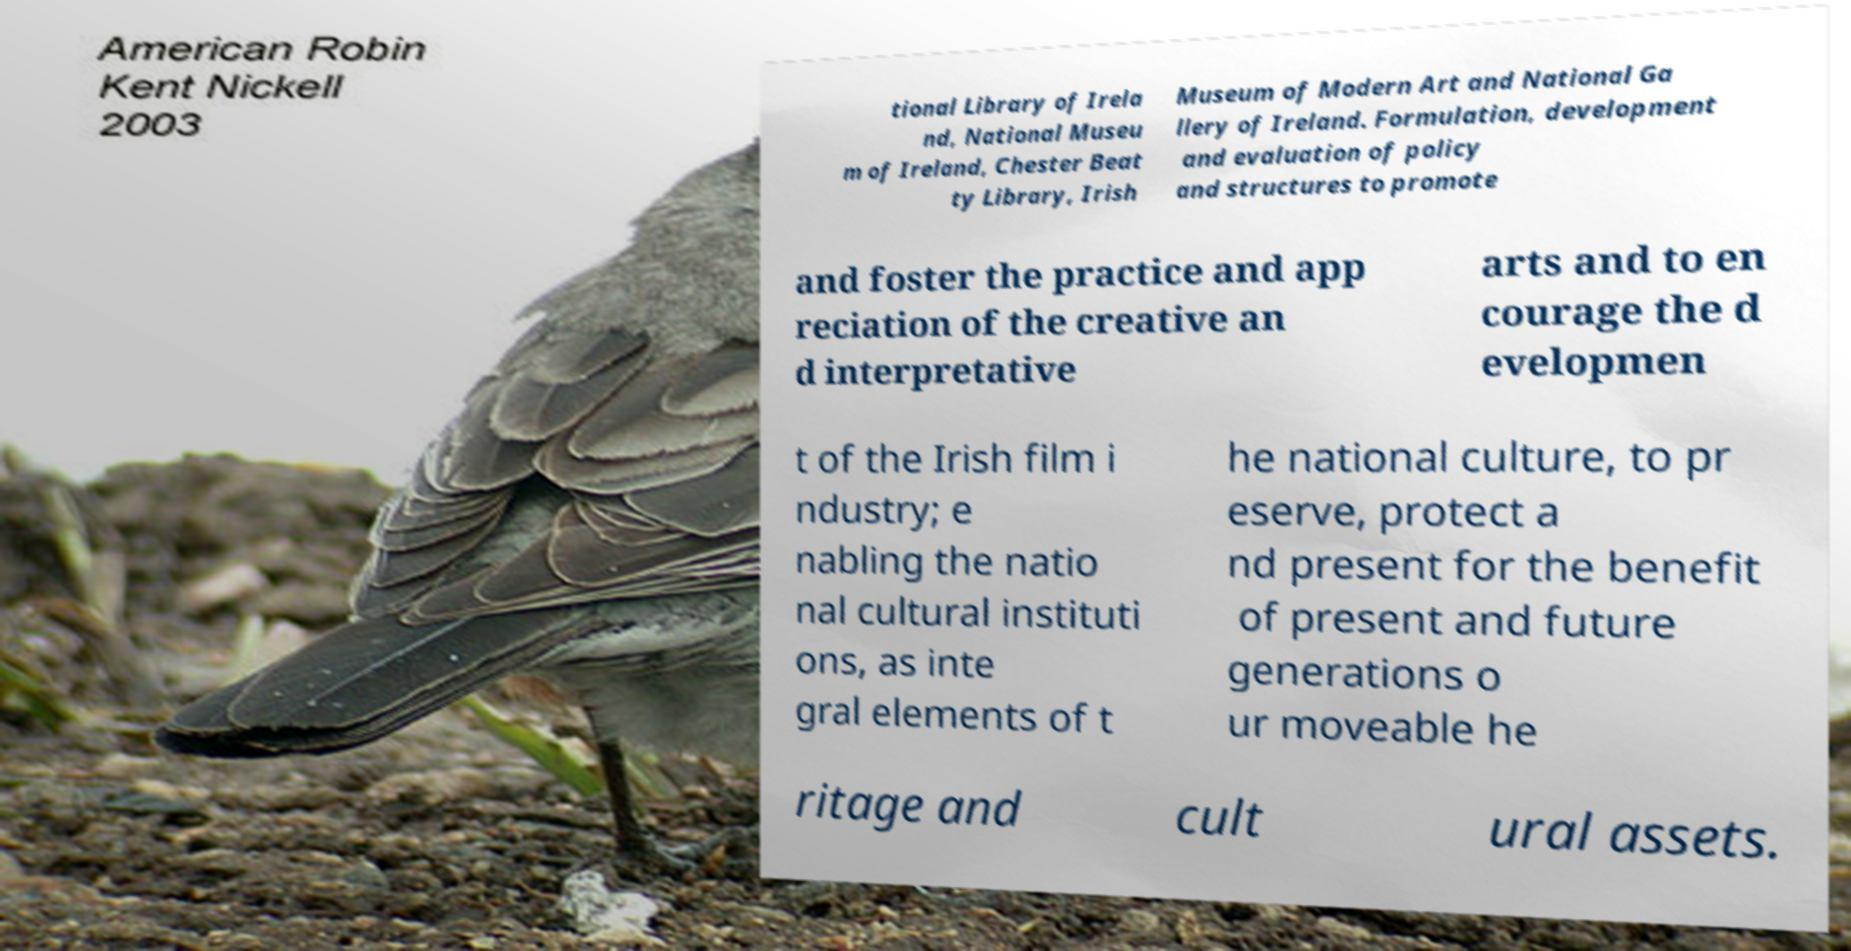Please identify and transcribe the text found in this image. tional Library of Irela nd, National Museu m of Ireland, Chester Beat ty Library, Irish Museum of Modern Art and National Ga llery of Ireland. Formulation, development and evaluation of policy and structures to promote and foster the practice and app reciation of the creative an d interpretative arts and to en courage the d evelopmen t of the Irish film i ndustry; e nabling the natio nal cultural instituti ons, as inte gral elements of t he national culture, to pr eserve, protect a nd present for the benefit of present and future generations o ur moveable he ritage and cult ural assets. 